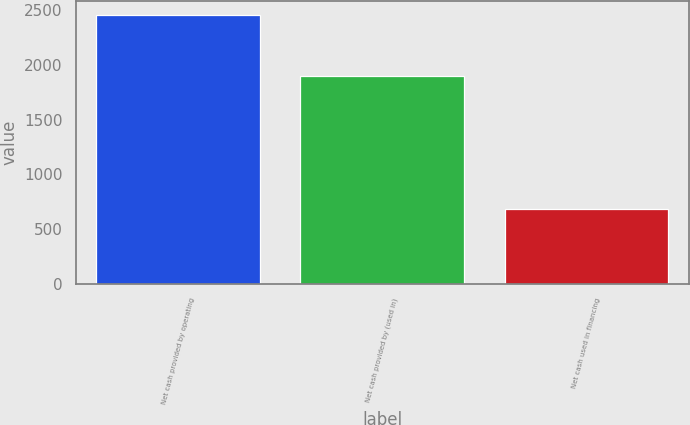Convert chart. <chart><loc_0><loc_0><loc_500><loc_500><bar_chart><fcel>Net cash provided by operating<fcel>Net cash provided by (used in)<fcel>Net cash used in financing<nl><fcel>2455<fcel>1900<fcel>687<nl></chart> 